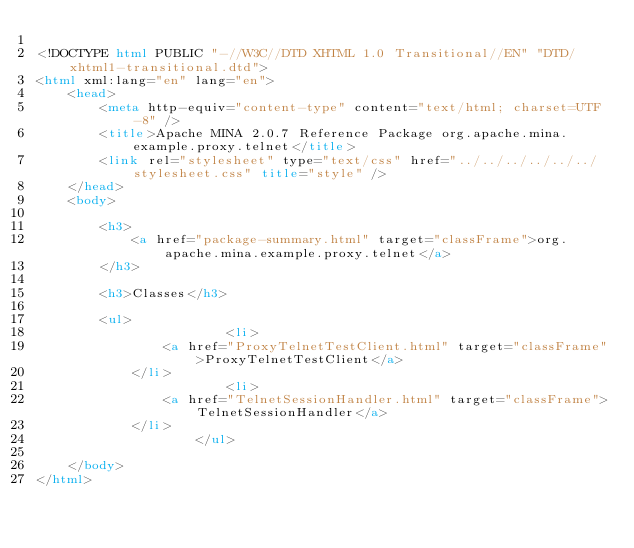Convert code to text. <code><loc_0><loc_0><loc_500><loc_500><_HTML_>
<!DOCTYPE html PUBLIC "-//W3C//DTD XHTML 1.0 Transitional//EN" "DTD/xhtml1-transitional.dtd">
<html xml:lang="en" lang="en">
	<head>
		<meta http-equiv="content-type" content="text/html; charset=UTF-8" />
		<title>Apache MINA 2.0.7 Reference Package org.apache.mina.example.proxy.telnet</title>
		<link rel="stylesheet" type="text/css" href="../../../../../../stylesheet.css" title="style" />
	</head>
	<body>

		<h3>
        	<a href="package-summary.html" target="classFrame">org.apache.mina.example.proxy.telnet</a>
      	</h3>

      	<h3>Classes</h3>

      	<ul>
      		          	<li>
            	<a href="ProxyTelnetTestClient.html" target="classFrame">ProxyTelnetTestClient</a>
          	</li>
          	          	<li>
            	<a href="TelnetSessionHandler.html" target="classFrame">TelnetSessionHandler</a>
          	</li>
          	      	</ul>

	</body>
</html></code> 